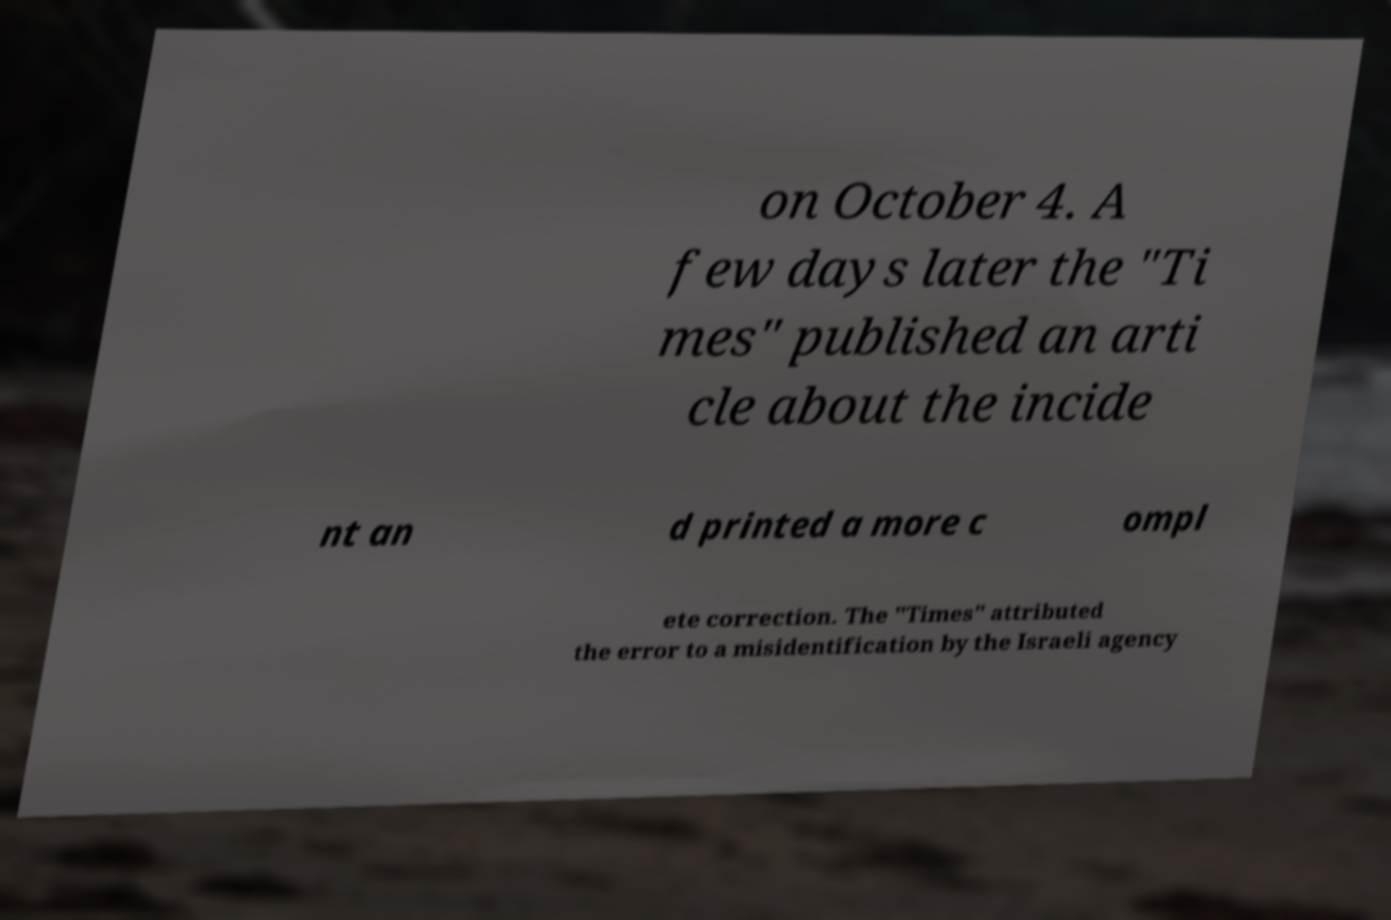Please read and relay the text visible in this image. What does it say? on October 4. A few days later the "Ti mes" published an arti cle about the incide nt an d printed a more c ompl ete correction. The "Times" attributed the error to a misidentification by the Israeli agency 